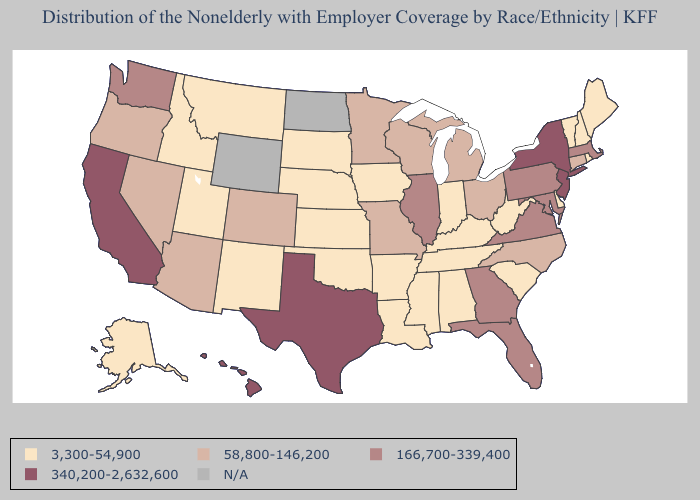Does Pennsylvania have the lowest value in the Northeast?
Quick response, please. No. What is the value of Maryland?
Keep it brief. 166,700-339,400. Which states have the lowest value in the USA?
Short answer required. Alabama, Alaska, Arkansas, Delaware, Idaho, Indiana, Iowa, Kansas, Kentucky, Louisiana, Maine, Mississippi, Montana, Nebraska, New Hampshire, New Mexico, Oklahoma, Rhode Island, South Carolina, South Dakota, Tennessee, Utah, Vermont, West Virginia. What is the lowest value in states that border New Hampshire?
Give a very brief answer. 3,300-54,900. Which states have the lowest value in the USA?
Write a very short answer. Alabama, Alaska, Arkansas, Delaware, Idaho, Indiana, Iowa, Kansas, Kentucky, Louisiana, Maine, Mississippi, Montana, Nebraska, New Hampshire, New Mexico, Oklahoma, Rhode Island, South Carolina, South Dakota, Tennessee, Utah, Vermont, West Virginia. Is the legend a continuous bar?
Quick response, please. No. What is the value of North Dakota?
Keep it brief. N/A. Does Maryland have the lowest value in the South?
Answer briefly. No. Name the states that have a value in the range 58,800-146,200?
Concise answer only. Arizona, Colorado, Connecticut, Michigan, Minnesota, Missouri, Nevada, North Carolina, Ohio, Oregon, Wisconsin. What is the highest value in the USA?
Give a very brief answer. 340,200-2,632,600. Among the states that border Michigan , does Indiana have the lowest value?
Write a very short answer. Yes. What is the value of Idaho?
Give a very brief answer. 3,300-54,900. Which states have the lowest value in the West?
Answer briefly. Alaska, Idaho, Montana, New Mexico, Utah. 